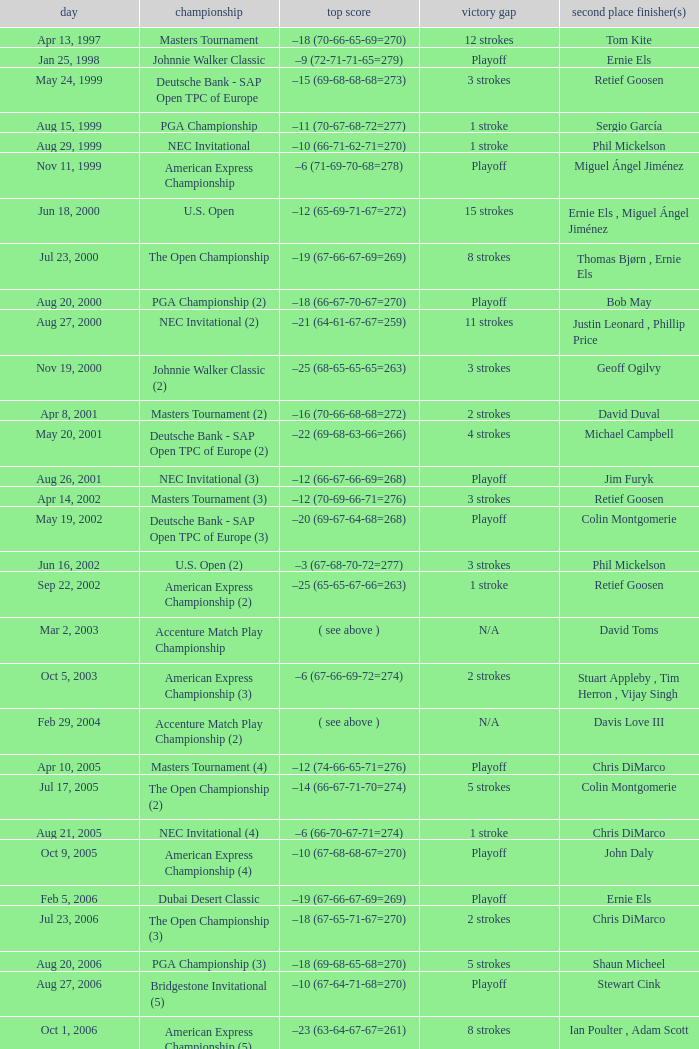Who is Runner(s)-up that has a Date of may 24, 1999? Retief Goosen. 